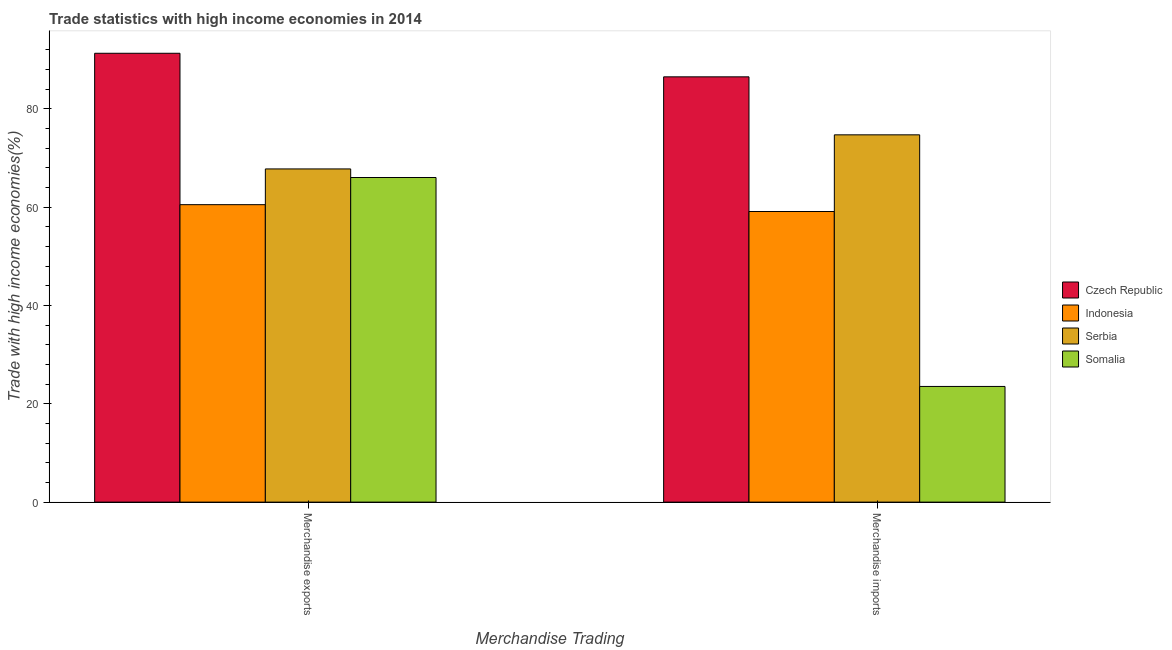How many different coloured bars are there?
Offer a terse response. 4. How many groups of bars are there?
Ensure brevity in your answer.  2. How many bars are there on the 1st tick from the left?
Provide a succinct answer. 4. What is the merchandise imports in Serbia?
Keep it short and to the point. 74.71. Across all countries, what is the maximum merchandise imports?
Offer a very short reply. 86.5. Across all countries, what is the minimum merchandise exports?
Keep it short and to the point. 60.5. In which country was the merchandise imports maximum?
Provide a succinct answer. Czech Republic. What is the total merchandise exports in the graph?
Provide a succinct answer. 285.6. What is the difference between the merchandise exports in Serbia and that in Somalia?
Your answer should be compact. 1.75. What is the difference between the merchandise exports in Czech Republic and the merchandise imports in Indonesia?
Keep it short and to the point. 32.19. What is the average merchandise imports per country?
Your response must be concise. 60.96. What is the difference between the merchandise imports and merchandise exports in Indonesia?
Give a very brief answer. -1.39. What is the ratio of the merchandise exports in Indonesia to that in Somalia?
Your answer should be compact. 0.92. Is the merchandise exports in Czech Republic less than that in Somalia?
Your answer should be very brief. No. What does the 4th bar from the left in Merchandise imports represents?
Provide a succinct answer. Somalia. What does the 1st bar from the right in Merchandise exports represents?
Offer a very short reply. Somalia. How many bars are there?
Ensure brevity in your answer.  8. Are all the bars in the graph horizontal?
Provide a succinct answer. No. What is the difference between two consecutive major ticks on the Y-axis?
Your answer should be very brief. 20. What is the title of the graph?
Your answer should be very brief. Trade statistics with high income economies in 2014. What is the label or title of the X-axis?
Offer a terse response. Merchandise Trading. What is the label or title of the Y-axis?
Make the answer very short. Trade with high income economies(%). What is the Trade with high income economies(%) of Czech Republic in Merchandise exports?
Your response must be concise. 91.3. What is the Trade with high income economies(%) of Indonesia in Merchandise exports?
Your answer should be very brief. 60.5. What is the Trade with high income economies(%) of Serbia in Merchandise exports?
Offer a very short reply. 67.77. What is the Trade with high income economies(%) in Somalia in Merchandise exports?
Ensure brevity in your answer.  66.03. What is the Trade with high income economies(%) of Czech Republic in Merchandise imports?
Ensure brevity in your answer.  86.5. What is the Trade with high income economies(%) in Indonesia in Merchandise imports?
Your answer should be very brief. 59.11. What is the Trade with high income economies(%) in Serbia in Merchandise imports?
Offer a terse response. 74.71. What is the Trade with high income economies(%) of Somalia in Merchandise imports?
Keep it short and to the point. 23.53. Across all Merchandise Trading, what is the maximum Trade with high income economies(%) in Czech Republic?
Offer a very short reply. 91.3. Across all Merchandise Trading, what is the maximum Trade with high income economies(%) of Indonesia?
Ensure brevity in your answer.  60.5. Across all Merchandise Trading, what is the maximum Trade with high income economies(%) in Serbia?
Give a very brief answer. 74.71. Across all Merchandise Trading, what is the maximum Trade with high income economies(%) of Somalia?
Provide a succinct answer. 66.03. Across all Merchandise Trading, what is the minimum Trade with high income economies(%) of Czech Republic?
Offer a terse response. 86.5. Across all Merchandise Trading, what is the minimum Trade with high income economies(%) of Indonesia?
Provide a succinct answer. 59.11. Across all Merchandise Trading, what is the minimum Trade with high income economies(%) in Serbia?
Provide a succinct answer. 67.77. Across all Merchandise Trading, what is the minimum Trade with high income economies(%) in Somalia?
Offer a very short reply. 23.53. What is the total Trade with high income economies(%) of Czech Republic in the graph?
Offer a terse response. 177.8. What is the total Trade with high income economies(%) in Indonesia in the graph?
Your response must be concise. 119.61. What is the total Trade with high income economies(%) in Serbia in the graph?
Your answer should be compact. 142.48. What is the total Trade with high income economies(%) in Somalia in the graph?
Your answer should be compact. 89.56. What is the difference between the Trade with high income economies(%) of Czech Republic in Merchandise exports and that in Merchandise imports?
Provide a short and direct response. 4.8. What is the difference between the Trade with high income economies(%) in Indonesia in Merchandise exports and that in Merchandise imports?
Keep it short and to the point. 1.39. What is the difference between the Trade with high income economies(%) of Serbia in Merchandise exports and that in Merchandise imports?
Give a very brief answer. -6.93. What is the difference between the Trade with high income economies(%) in Somalia in Merchandise exports and that in Merchandise imports?
Provide a succinct answer. 42.5. What is the difference between the Trade with high income economies(%) in Czech Republic in Merchandise exports and the Trade with high income economies(%) in Indonesia in Merchandise imports?
Your answer should be very brief. 32.19. What is the difference between the Trade with high income economies(%) of Czech Republic in Merchandise exports and the Trade with high income economies(%) of Serbia in Merchandise imports?
Offer a terse response. 16.59. What is the difference between the Trade with high income economies(%) in Czech Republic in Merchandise exports and the Trade with high income economies(%) in Somalia in Merchandise imports?
Your answer should be very brief. 67.77. What is the difference between the Trade with high income economies(%) in Indonesia in Merchandise exports and the Trade with high income economies(%) in Serbia in Merchandise imports?
Keep it short and to the point. -14.2. What is the difference between the Trade with high income economies(%) in Indonesia in Merchandise exports and the Trade with high income economies(%) in Somalia in Merchandise imports?
Provide a succinct answer. 36.97. What is the difference between the Trade with high income economies(%) in Serbia in Merchandise exports and the Trade with high income economies(%) in Somalia in Merchandise imports?
Offer a terse response. 44.24. What is the average Trade with high income economies(%) of Czech Republic per Merchandise Trading?
Your response must be concise. 88.9. What is the average Trade with high income economies(%) of Indonesia per Merchandise Trading?
Ensure brevity in your answer.  59.81. What is the average Trade with high income economies(%) in Serbia per Merchandise Trading?
Ensure brevity in your answer.  71.24. What is the average Trade with high income economies(%) of Somalia per Merchandise Trading?
Your answer should be compact. 44.78. What is the difference between the Trade with high income economies(%) of Czech Republic and Trade with high income economies(%) of Indonesia in Merchandise exports?
Provide a succinct answer. 30.79. What is the difference between the Trade with high income economies(%) in Czech Republic and Trade with high income economies(%) in Serbia in Merchandise exports?
Your response must be concise. 23.52. What is the difference between the Trade with high income economies(%) of Czech Republic and Trade with high income economies(%) of Somalia in Merchandise exports?
Your answer should be compact. 25.27. What is the difference between the Trade with high income economies(%) of Indonesia and Trade with high income economies(%) of Serbia in Merchandise exports?
Your response must be concise. -7.27. What is the difference between the Trade with high income economies(%) in Indonesia and Trade with high income economies(%) in Somalia in Merchandise exports?
Offer a very short reply. -5.52. What is the difference between the Trade with high income economies(%) of Serbia and Trade with high income economies(%) of Somalia in Merchandise exports?
Give a very brief answer. 1.75. What is the difference between the Trade with high income economies(%) in Czech Republic and Trade with high income economies(%) in Indonesia in Merchandise imports?
Keep it short and to the point. 27.39. What is the difference between the Trade with high income economies(%) in Czech Republic and Trade with high income economies(%) in Serbia in Merchandise imports?
Provide a short and direct response. 11.8. What is the difference between the Trade with high income economies(%) in Czech Republic and Trade with high income economies(%) in Somalia in Merchandise imports?
Provide a short and direct response. 62.97. What is the difference between the Trade with high income economies(%) of Indonesia and Trade with high income economies(%) of Serbia in Merchandise imports?
Give a very brief answer. -15.6. What is the difference between the Trade with high income economies(%) in Indonesia and Trade with high income economies(%) in Somalia in Merchandise imports?
Provide a succinct answer. 35.58. What is the difference between the Trade with high income economies(%) of Serbia and Trade with high income economies(%) of Somalia in Merchandise imports?
Your response must be concise. 51.18. What is the ratio of the Trade with high income economies(%) in Czech Republic in Merchandise exports to that in Merchandise imports?
Offer a very short reply. 1.06. What is the ratio of the Trade with high income economies(%) in Indonesia in Merchandise exports to that in Merchandise imports?
Your response must be concise. 1.02. What is the ratio of the Trade with high income economies(%) in Serbia in Merchandise exports to that in Merchandise imports?
Your answer should be compact. 0.91. What is the ratio of the Trade with high income economies(%) in Somalia in Merchandise exports to that in Merchandise imports?
Your response must be concise. 2.81. What is the difference between the highest and the second highest Trade with high income economies(%) in Czech Republic?
Provide a short and direct response. 4.8. What is the difference between the highest and the second highest Trade with high income economies(%) in Indonesia?
Give a very brief answer. 1.39. What is the difference between the highest and the second highest Trade with high income economies(%) in Serbia?
Offer a very short reply. 6.93. What is the difference between the highest and the second highest Trade with high income economies(%) in Somalia?
Provide a short and direct response. 42.5. What is the difference between the highest and the lowest Trade with high income economies(%) in Czech Republic?
Your answer should be compact. 4.8. What is the difference between the highest and the lowest Trade with high income economies(%) of Indonesia?
Make the answer very short. 1.39. What is the difference between the highest and the lowest Trade with high income economies(%) of Serbia?
Ensure brevity in your answer.  6.93. What is the difference between the highest and the lowest Trade with high income economies(%) of Somalia?
Your response must be concise. 42.5. 